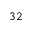<formula> <loc_0><loc_0><loc_500><loc_500>3 2</formula> 